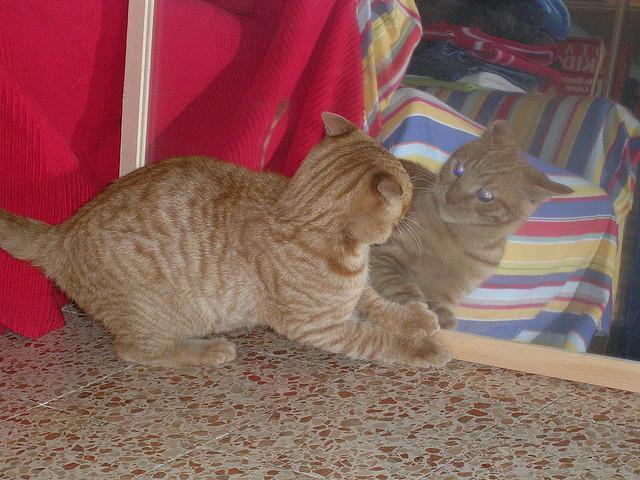How many cat's in the photo?
Give a very brief answer. 1. 